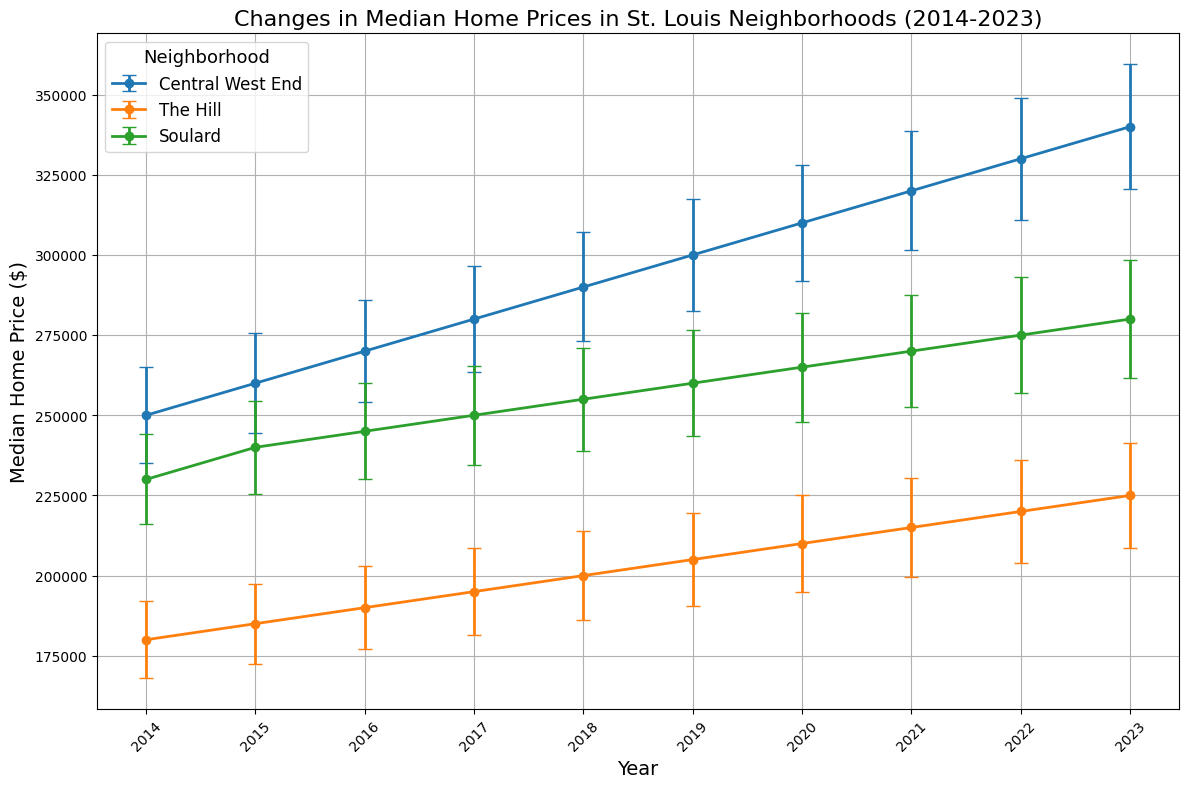What's the trend in median home prices for Central West End from 2014 to 2023? The plot shows a gradual increase in the median home prices for Central West End from 2014 ($250,000) to 2023 ($340,000). Each year, the prices steadily rise by approximately $10,000 or more, indicating consistent growth over the decade.
Answer: Increasing Which neighborhood had the highest median home price in 2019? The median home prices for 2019 are shown for all neighborhoods. The Central West End had the highest median home price in 2019 at $300,000 compared to The Hill at $205,000 and Soulard at $260,000.
Answer: Central West End Which neighborhood shows the smallest change in median home prices from 2014 to 2023? To determine the smallest change, compare the difference in home prices from 2014 to 2023 for each neighborhood. Central West End increased by $90,000 ($340,000 - $250,000), The Hill increased by $45,000 ($225,000 - $180,000), and Soulard increased by $50,000 ($280,000 - $230,000). The Hill shows the smallest change with a $45,000 increase.
Answer: The Hill Are the error bars for home prices wider in 2023 compared to 2014 for all neighborhoods? The width of the error bars represents the standard error. By looking at the plot, all neighborhoods have wider error bars in 2023 compared to 2014: Central West End (from $15,000 to $19,500), The Hill (from $12,000 to $16,500), and Soulard (from $14,000 to $18,500).
Answer: Yes In which year did Soulard's median home price exceed $250,000 for the first time? By looking at the plot, Soulard's median home price exceeds $250,000 in 2017, as it is shown at $250,000, and it remains above $250,000 in all subsequent years.
Answer: 2017 Which year saw the largest year-over-year increase in median home prices for The Hill? Inspect the plotted data for The Hill, where the largest year-over-year increase in median home prices occurred between 2019 and 2020, rising from $205,000 to $210,000, an increase of $5,000.
Answer: 2019-2020 How do the slopes of the median home price lines compare among the neighborhoods over the decade? By observing the steepness of the lines for each neighborhood: Central West End shows the steepest slope indicating the fastest price growth, followed by Soulard, and The Hill shows the gentlest slope indicating the slowest growth rate.
Answer: Central West End > Soulard > The Hill What is the median value of The Hill's home prices in the dataset provided? To find the median value, list The Hill's home prices: $180,000, $185,000, $190,000, $195,000, $200,000, $205,000, $210,000, $215,000, $220,000, $225,000. The median is the middle value which, for an even number of values, is the average of the two middle ones (200,000 and 205,000): (200,000 + 205,000) / 2 = $202,500.
Answer: $202,500 